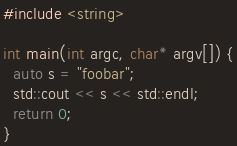Convert code to text. <code><loc_0><loc_0><loc_500><loc_500><_C++_>#include <string>

int main(int argc, char* argv[]) {
  auto s = "foobar";
  std::cout << s << std::endl;
  return 0;
}
</code> 